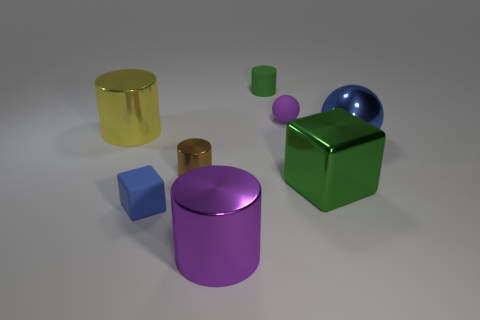What number of large yellow cylinders are made of the same material as the green cube?
Offer a terse response. 1. What number of objects are purple things that are on the left side of the tiny purple rubber ball or small cylinders that are behind the large blue metallic ball?
Give a very brief answer. 2. Are there more large metallic objects on the right side of the purple cylinder than yellow metallic objects that are behind the yellow shiny cylinder?
Your response must be concise. Yes. What is the color of the big cylinder that is behind the purple cylinder?
Offer a very short reply. Yellow. Is there another rubber object that has the same shape as the small brown thing?
Provide a short and direct response. Yes. What number of blue things are tiny objects or rubber cylinders?
Make the answer very short. 1. Is there a green matte cylinder of the same size as the shiny sphere?
Make the answer very short. No. What number of tiny brown shiny cylinders are there?
Provide a succinct answer. 1. What number of small things are red matte things or matte objects?
Keep it short and to the point. 3. There is a big cylinder to the left of the large cylinder in front of the shiny object that is on the left side of the tiny brown cylinder; what color is it?
Your answer should be very brief. Yellow. 